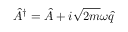Convert formula to latex. <formula><loc_0><loc_0><loc_500><loc_500>\hat { A } ^ { \dagger } = \hat { A } + i \sqrt { 2 m } \omega \hat { q }</formula> 